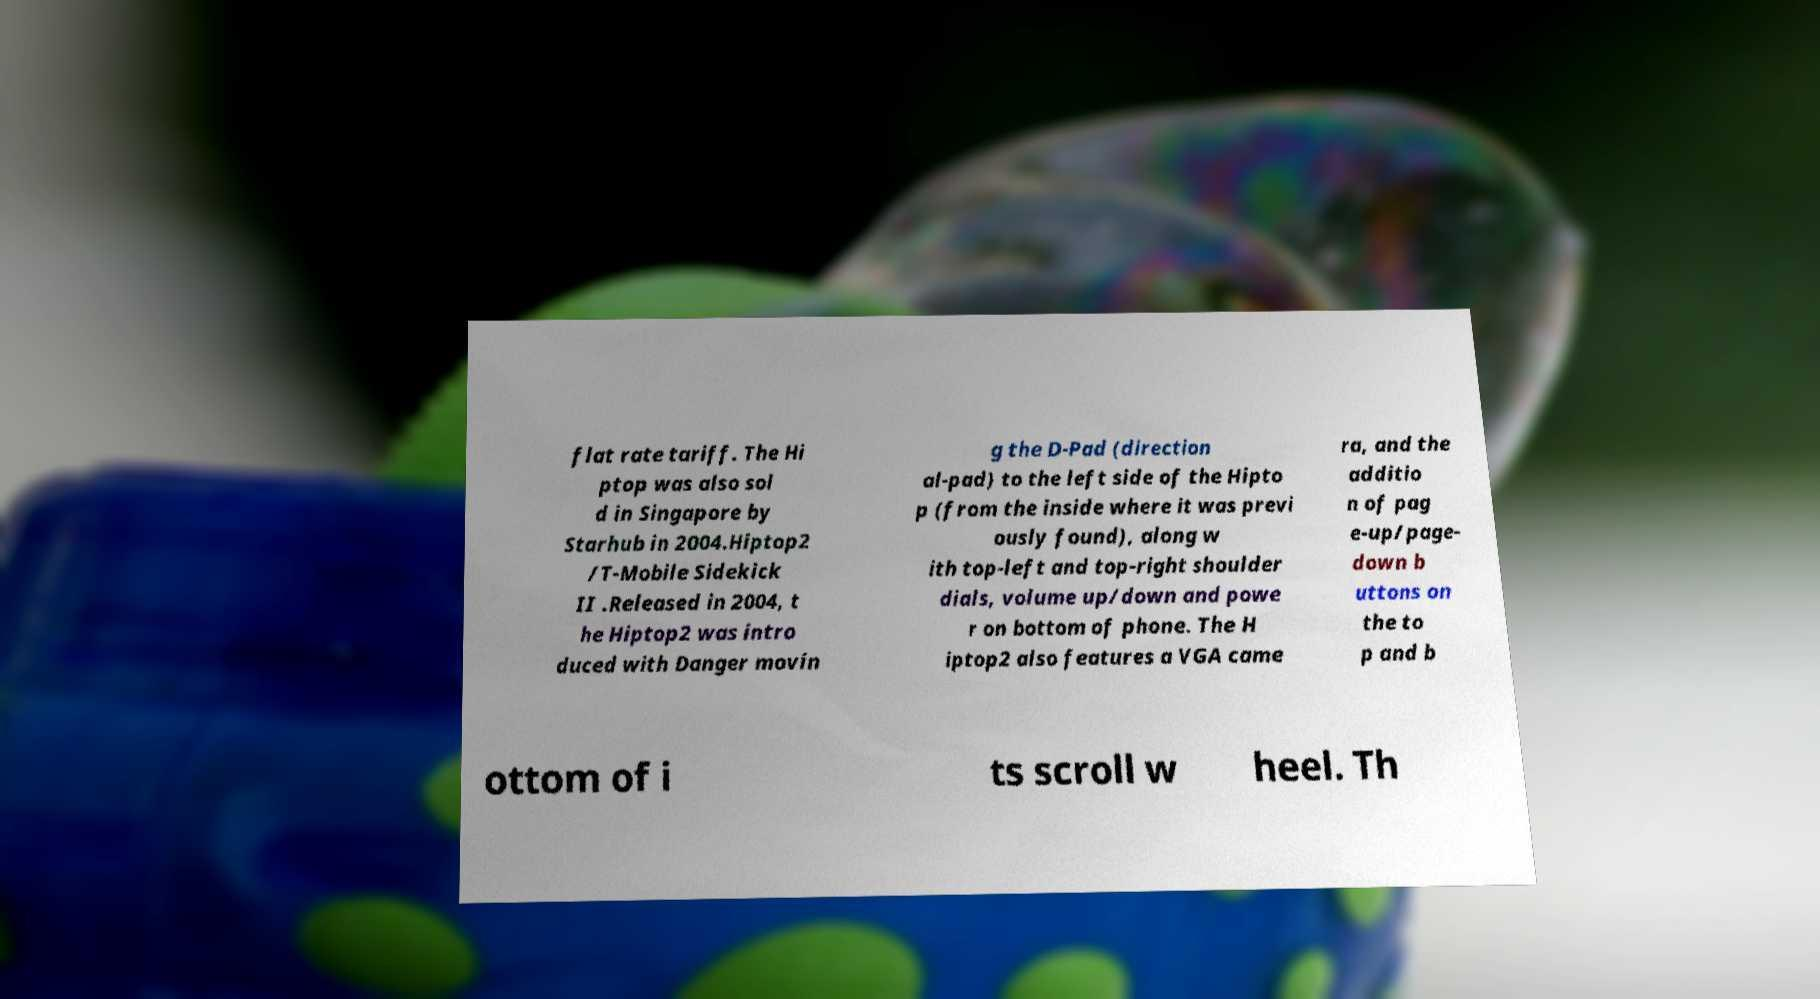What messages or text are displayed in this image? I need them in a readable, typed format. flat rate tariff. The Hi ptop was also sol d in Singapore by Starhub in 2004.Hiptop2 /T-Mobile Sidekick II .Released in 2004, t he Hiptop2 was intro duced with Danger movin g the D-Pad (direction al-pad) to the left side of the Hipto p (from the inside where it was previ ously found), along w ith top-left and top-right shoulder dials, volume up/down and powe r on bottom of phone. The H iptop2 also features a VGA came ra, and the additio n of pag e-up/page- down b uttons on the to p and b ottom of i ts scroll w heel. Th 